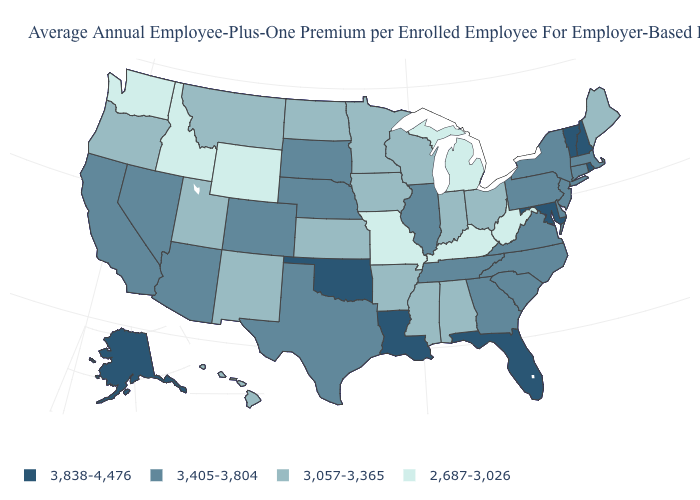Does Idaho have the same value as Wyoming?
Be succinct. Yes. What is the value of Washington?
Give a very brief answer. 2,687-3,026. What is the value of Mississippi?
Give a very brief answer. 3,057-3,365. Which states hav the highest value in the MidWest?
Give a very brief answer. Illinois, Nebraska, South Dakota. What is the value of North Carolina?
Short answer required. 3,405-3,804. What is the value of Oklahoma?
Quick response, please. 3,838-4,476. Is the legend a continuous bar?
Quick response, please. No. What is the lowest value in the USA?
Keep it brief. 2,687-3,026. How many symbols are there in the legend?
Be succinct. 4. How many symbols are there in the legend?
Answer briefly. 4. What is the value of West Virginia?
Keep it brief. 2,687-3,026. Does West Virginia have the lowest value in the South?
Concise answer only. Yes. Name the states that have a value in the range 3,057-3,365?
Concise answer only. Alabama, Arkansas, Hawaii, Indiana, Iowa, Kansas, Maine, Minnesota, Mississippi, Montana, New Mexico, North Dakota, Ohio, Oregon, Utah, Wisconsin. Name the states that have a value in the range 3,838-4,476?
Quick response, please. Alaska, Florida, Louisiana, Maryland, New Hampshire, Oklahoma, Rhode Island, Vermont. What is the highest value in the USA?
Short answer required. 3,838-4,476. 